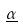<formula> <loc_0><loc_0><loc_500><loc_500>\underline { \alpha }</formula> 